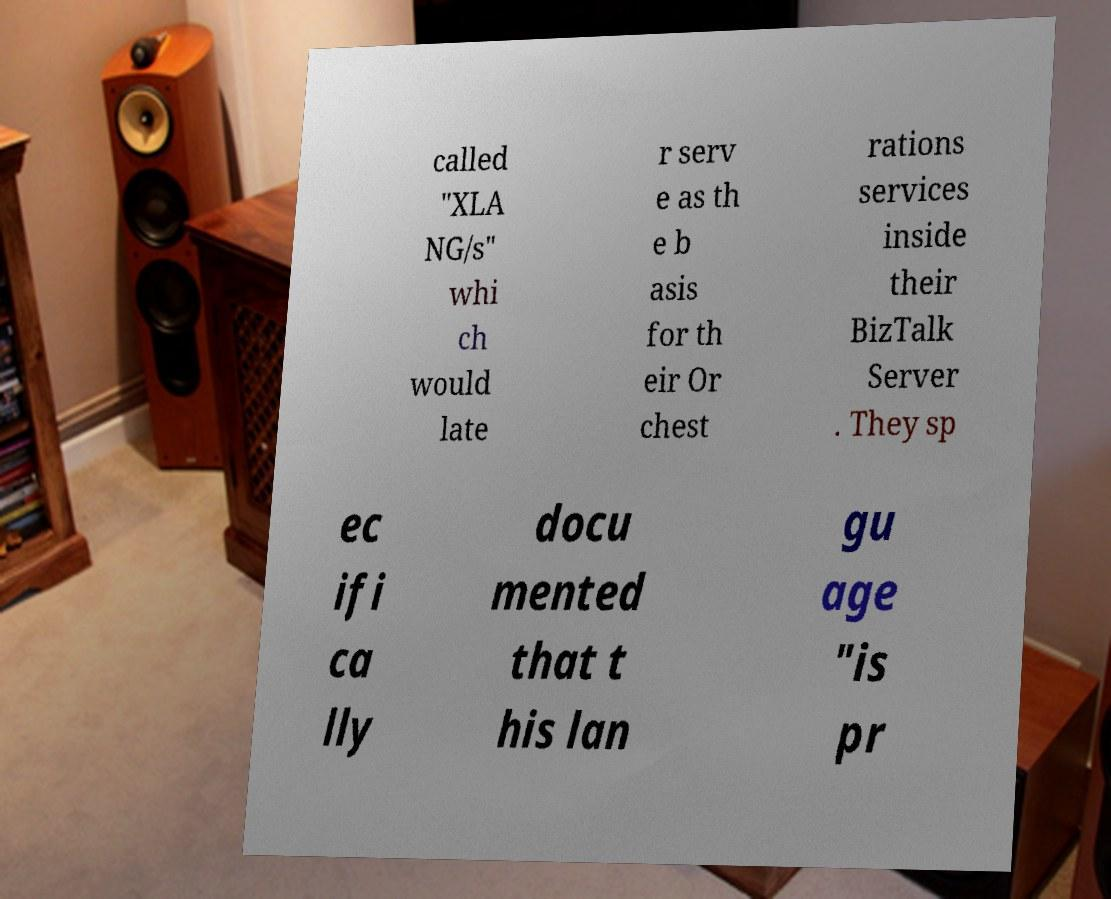What messages or text are displayed in this image? I need them in a readable, typed format. called "XLA NG/s" whi ch would late r serv e as th e b asis for th eir Or chest rations services inside their BizTalk Server . They sp ec ifi ca lly docu mented that t his lan gu age "is pr 